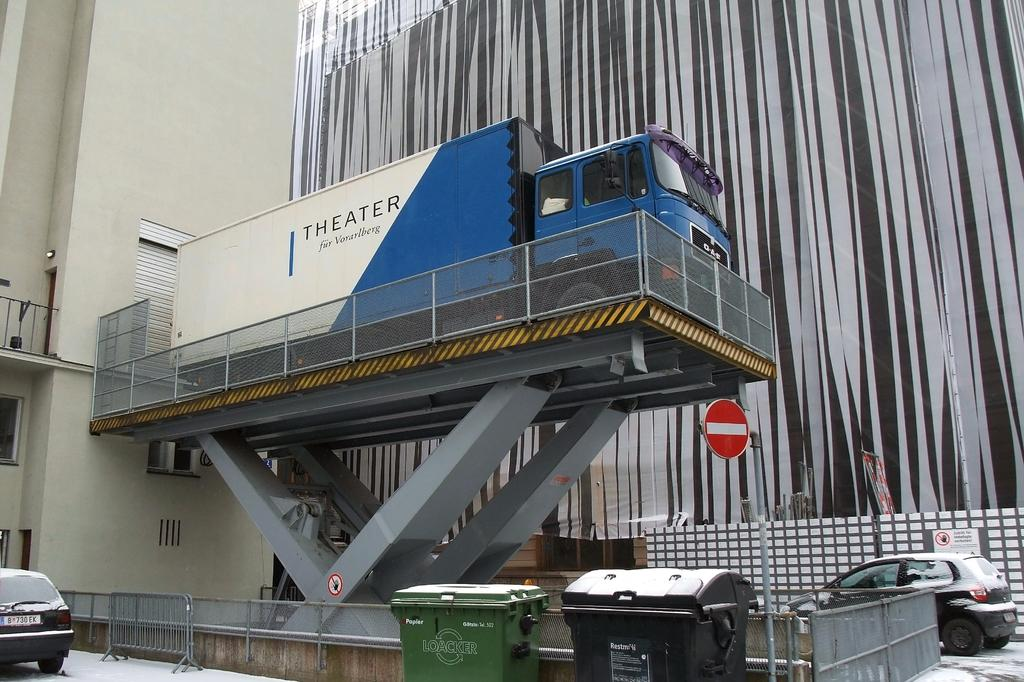Provide a one-sentence caption for the provided image. White and blue truck which says THEATER  on it. 